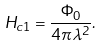<formula> <loc_0><loc_0><loc_500><loc_500>H _ { c 1 } = \frac { \Phi _ { 0 } } { 4 \pi \lambda ^ { 2 } } .</formula> 